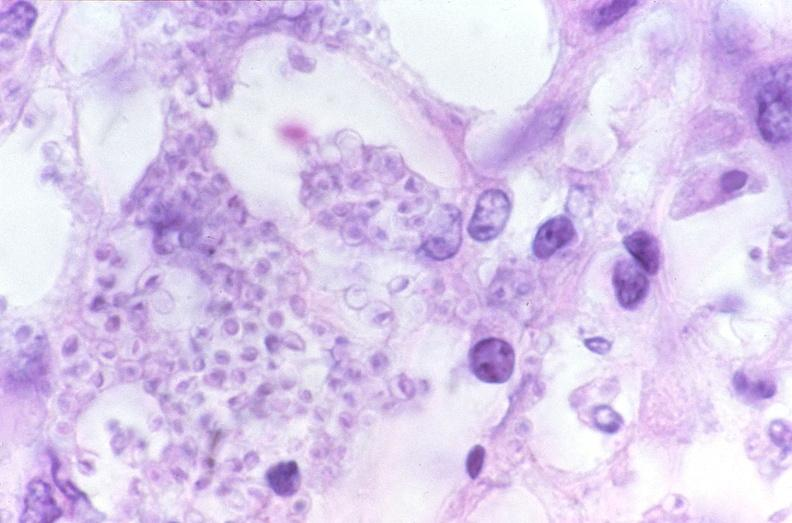s there present?
Answer the question using a single word or phrase. No 